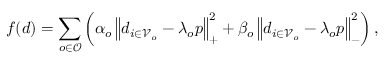Convert formula to latex. <formula><loc_0><loc_0><loc_500><loc_500>f ( d ) = \sum _ { o \in \mathcal { O } } \left ( \alpha _ { o } \left \| d _ { i \in \mathcal { V } _ { o } } - \lambda _ { o } p \right \| _ { + } ^ { 2 } + \beta _ { o } \left \| d _ { i \in \mathcal { V } _ { o } } - \lambda _ { o } p \right \| _ { - } ^ { 2 } \right ) ,</formula> 